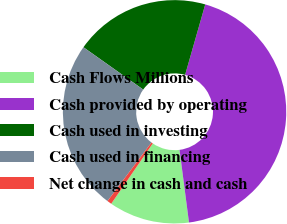Convert chart to OTSL. <chart><loc_0><loc_0><loc_500><loc_500><pie_chart><fcel>Cash Flows Millions<fcel>Cash provided by operating<fcel>Cash used in investing<fcel>Cash used in financing<fcel>Net change in cash and cash<nl><fcel>11.66%<fcel>43.51%<fcel>19.62%<fcel>24.55%<fcel>0.66%<nl></chart> 